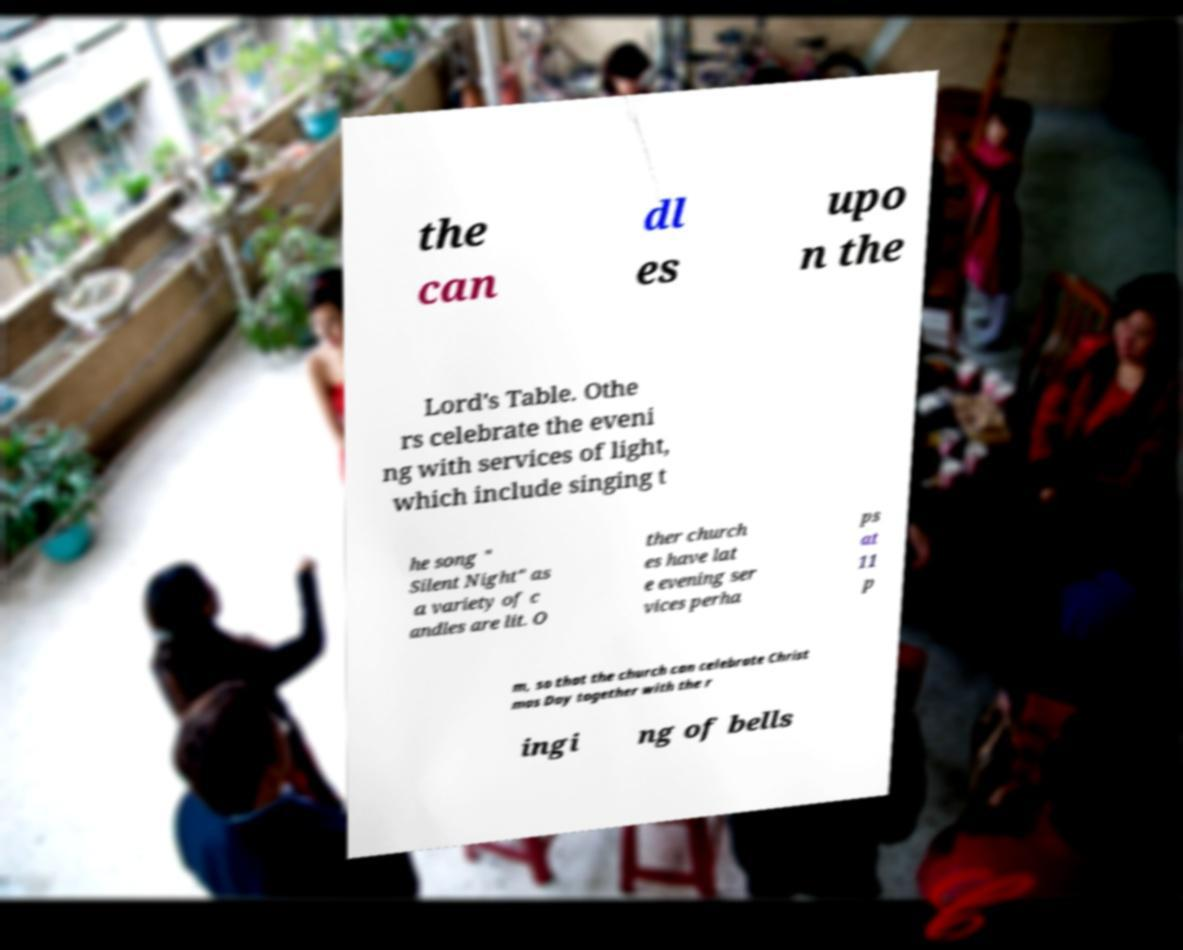What messages or text are displayed in this image? I need them in a readable, typed format. the can dl es upo n the Lord's Table. Othe rs celebrate the eveni ng with services of light, which include singing t he song " Silent Night" as a variety of c andles are lit. O ther church es have lat e evening ser vices perha ps at 11 p m, so that the church can celebrate Christ mas Day together with the r ingi ng of bells 